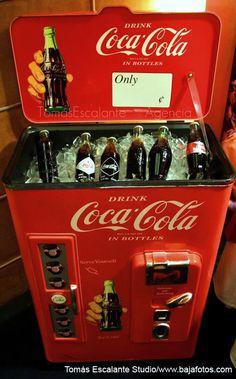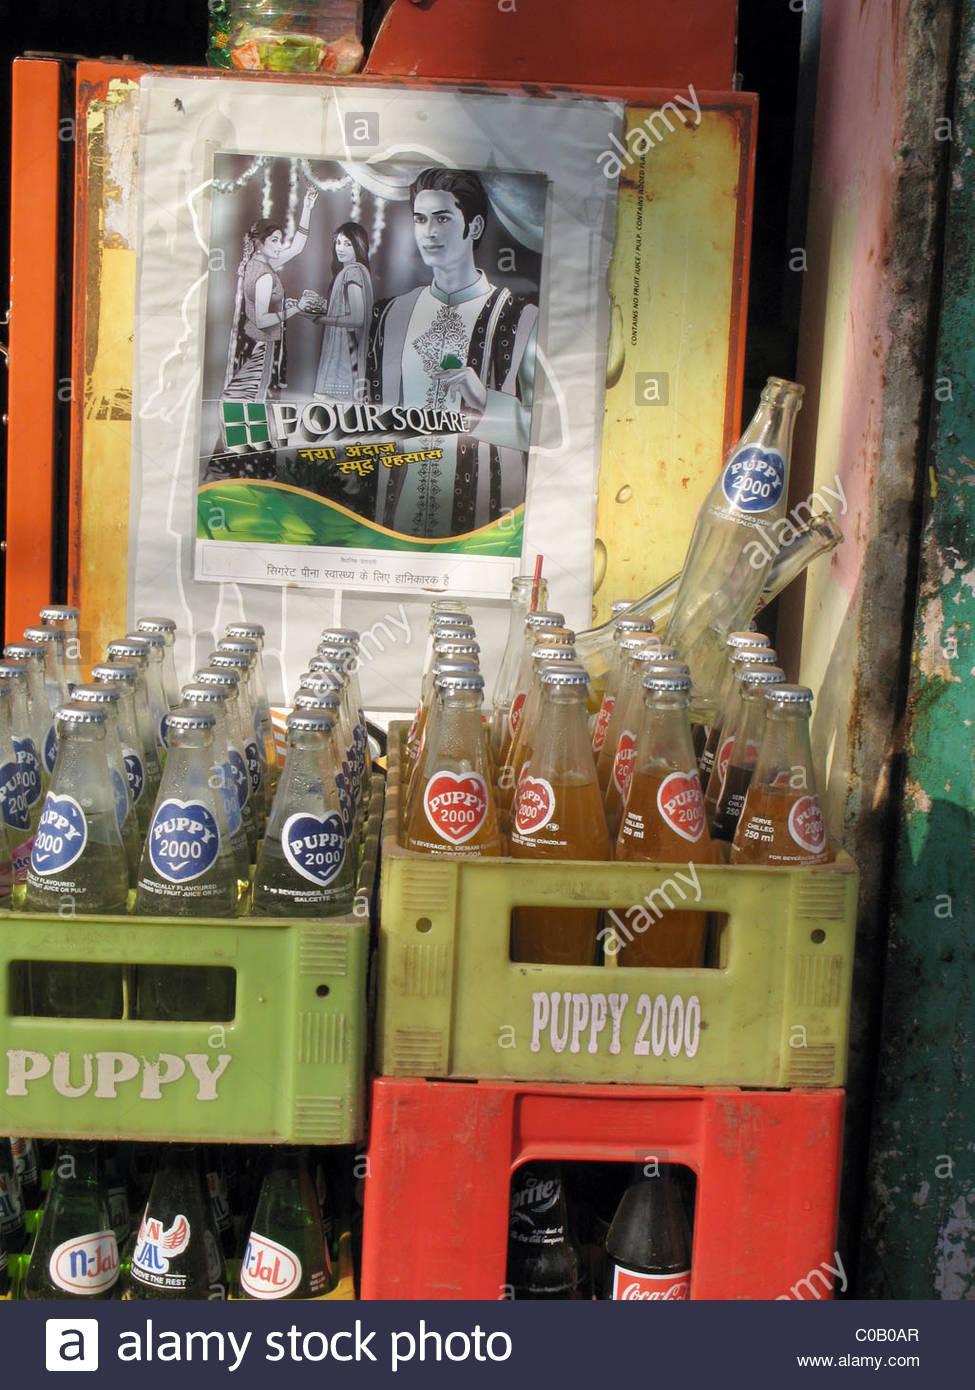The first image is the image on the left, the second image is the image on the right. For the images displayed, is the sentence "The bottles in the left image are unopened." factually correct? Answer yes or no. Yes. The first image is the image on the left, the second image is the image on the right. Considering the images on both sides, is "The left image features filled cola bottles in a red wooden crate with low sides." valid? Answer yes or no. No. 